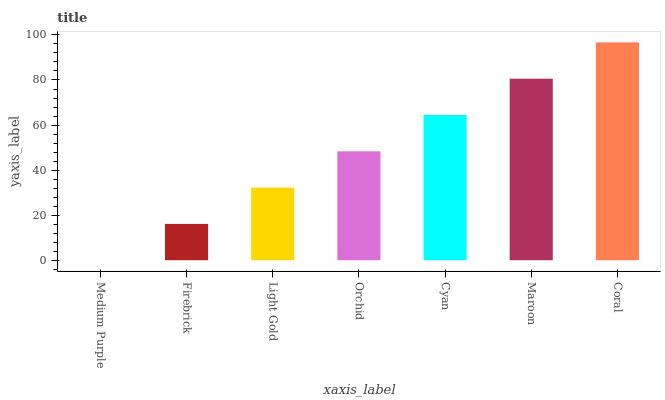Is Medium Purple the minimum?
Answer yes or no. Yes. Is Coral the maximum?
Answer yes or no. Yes. Is Firebrick the minimum?
Answer yes or no. No. Is Firebrick the maximum?
Answer yes or no. No. Is Firebrick greater than Medium Purple?
Answer yes or no. Yes. Is Medium Purple less than Firebrick?
Answer yes or no. Yes. Is Medium Purple greater than Firebrick?
Answer yes or no. No. Is Firebrick less than Medium Purple?
Answer yes or no. No. Is Orchid the high median?
Answer yes or no. Yes. Is Orchid the low median?
Answer yes or no. Yes. Is Light Gold the high median?
Answer yes or no. No. Is Maroon the low median?
Answer yes or no. No. 